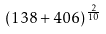Convert formula to latex. <formula><loc_0><loc_0><loc_500><loc_500>( 1 3 8 + 4 0 6 ) ^ { \frac { 2 } { 1 0 } }</formula> 